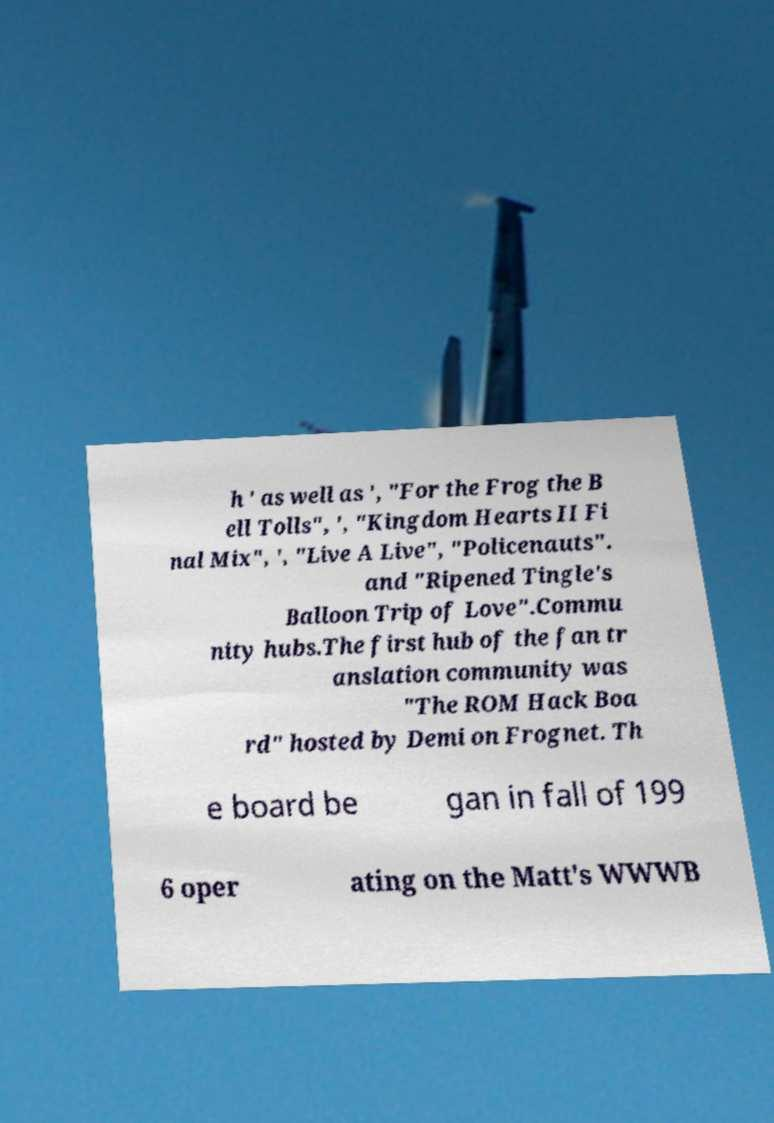What messages or text are displayed in this image? I need them in a readable, typed format. h ' as well as ', "For the Frog the B ell Tolls", ', "Kingdom Hearts II Fi nal Mix", ', "Live A Live", "Policenauts". and "Ripened Tingle's Balloon Trip of Love".Commu nity hubs.The first hub of the fan tr anslation community was "The ROM Hack Boa rd" hosted by Demi on Frognet. Th e board be gan in fall of 199 6 oper ating on the Matt's WWWB 